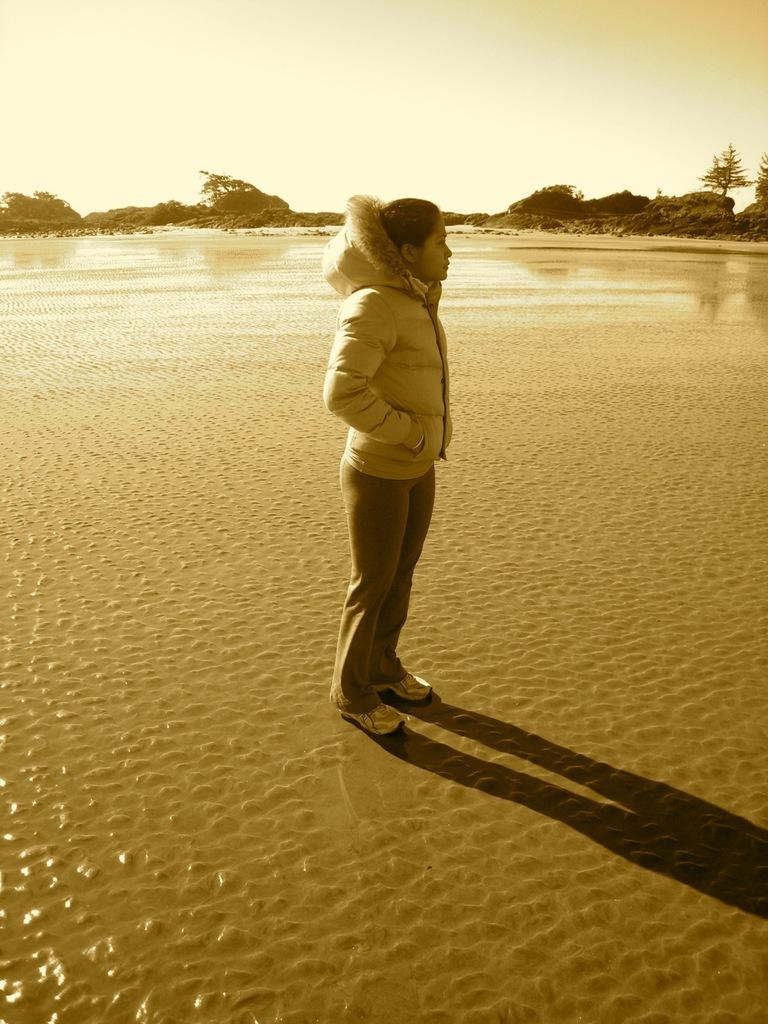What is the main subject of the image? There is a person standing in the image. What can be seen in the background of the image? The sky is visible in the background of the image. What type of natural environment is present in the image? There are trees in the image. What else is visible in the image besides the person? Water is visible in the image. What verse is being recited by the boys in the image? There are no boys present in the image, and no verse is being recited. Can you tell me how many yaks are visible in the image? There are no yaks present in the image. 